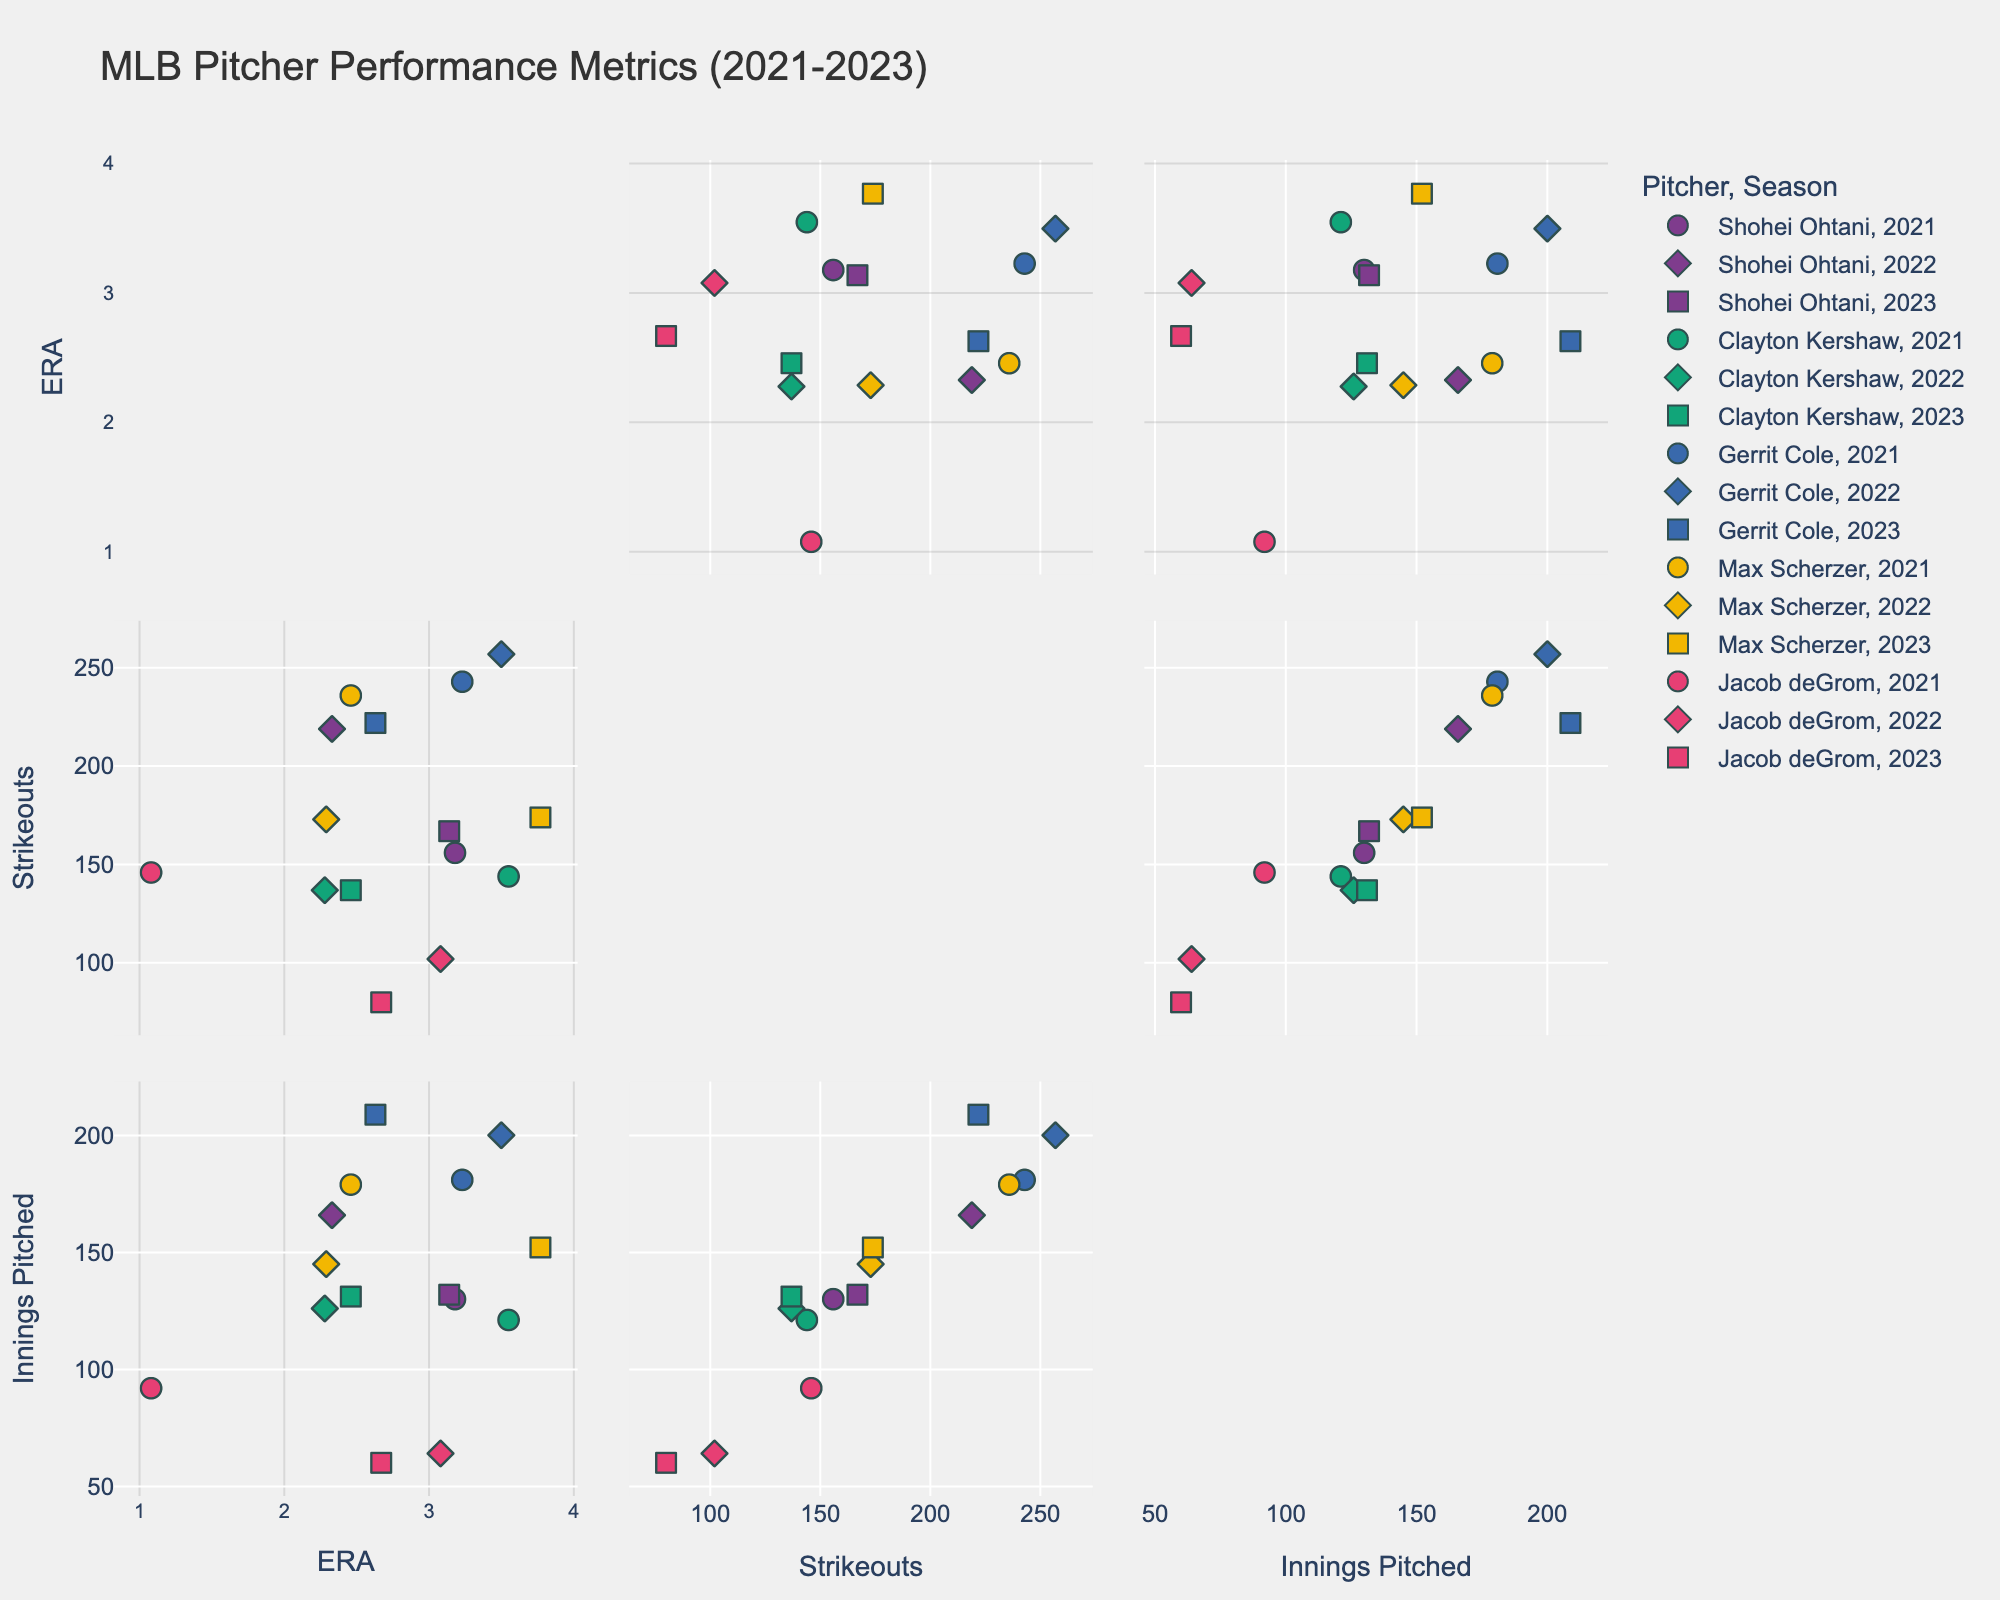How many pitchers are included in the scatterplot matrix? By looking at the legend of the scatterplot matrix, we can count the number of unique color codes or symbols assigned to different pitchers.
Answer: 5 How does Shohei Ohtani's ERA in 2021 compare to his ERA in 2022? By observing the scatterplot points for Shohei Ohtani, we can compare the ERA values for the 2021 and 2022 seasons. Shohei Ohtani's ERA in 2021 is indicated by one symbol, and in 2022 by another. We can see that his ERA decreased from 3.18 in 2021 to 2.33 in 2022.
Answer: 2022 ERA is lower Which pitcher has the lowest ERA in the data set? To find the lowest ERA, we look for the point with the smallest value on the ERA axis across all seasons and pitchers. Jacob deGrom's ERA in 2021 is the lowest at 1.08.
Answer: Jacob deGrom Do Max Scherzer's strikeouts increase or decrease from 2021 to 2023? By following the scatterplot points for Max Scherzer across the seasons, we can observe the trend in his strikeouts. There is a decrease from 236 strikeouts in 2021 to 173 in 2022, and then a slight increase to 174 in 2023.
Answer: Decrease from 2021 to 2022, slight increase to 2023 What is the range of innings pitched for Clayton Kershaw across the seasons? Looking at the scatterplot points for Clayton Kershaw, we see his innings pitched values for each season. The range is calculated as the difference between the maximum and minimum values. In 2021, 2022, and 2023, his innings pitched are 121.2, 126.1, and 131.2, respectively. So, the range is 131.2 - 121.2 = 10.
Answer: 10 innings Which pitcher had the highest strikeouts in a single season and what was that value? By identifying the highest point on the strikeouts axis, we determine that Gerrit Cole had the most strikeouts in 2022 with a value of 257.
Answer: Gerrit Cole, 257 strikeouts How did Jacob deGrom's ERA change from 2021 to 2022? By comparing Jacob deGrom's ERA values in the scatterplot matrix, we can see the change from 1.08 in 2021 to 3.08 in 2022. The ERA increased by 3.08 - 1.08 = 2.00.
Answer: Increased by 2.00 What correlation appears to exist between ERA and innings pitched for Shohei Ohtani? By examining the scatterplot matrix, we can observe the pattern of points corresponding to Shohei Ohtani for ERA and innings pitched. There appears to be a downward trend suggesting that as innings pitched increase, the ERA decreases.
Answer: Negative correlation Which pitcher has the most similar ERA in 2022 and 2023, and what is that value? By looking at the ERA values for each pitcher in 2022 and 2023, we compare the values and find Clayton Kershaw has very close ERA values of 2.28 in 2022 and 2.46 in 2023.
Answer: Clayton Kershaw, approximately 2.3 